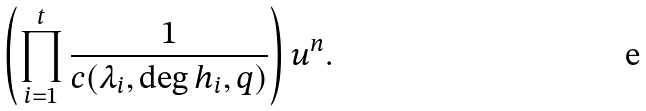<formula> <loc_0><loc_0><loc_500><loc_500>\left ( \prod _ { i = 1 } ^ { t } \frac { 1 } { c ( \lambda _ { i } , \deg h _ { i } , q ) } \right ) u ^ { n } .</formula> 